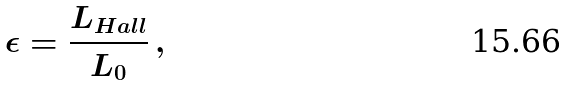Convert formula to latex. <formula><loc_0><loc_0><loc_500><loc_500>\epsilon = \frac { L _ { H a l l } } { L _ { 0 } } \, ,</formula> 